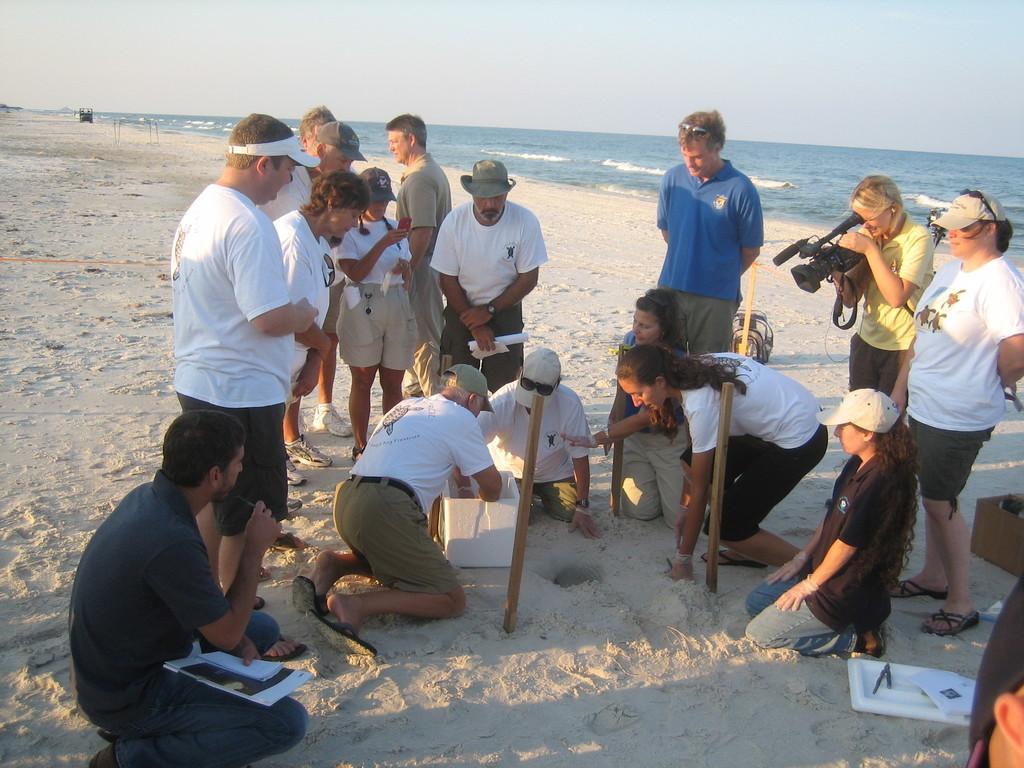Can you describe this image briefly? This image is taken outdoors. At the bottom of the image there is a ground. At the top of the image there is the sky. In the background there is a sea with water and waves. In the middle of the image a few people are sitting on a ground and there are two wooden sticks and a few are standing on the ground. On the right side of the image to women are standing on the ground and a woman is holding a camera in her hands. There is a cardboard box and there are a few things on the ground. 